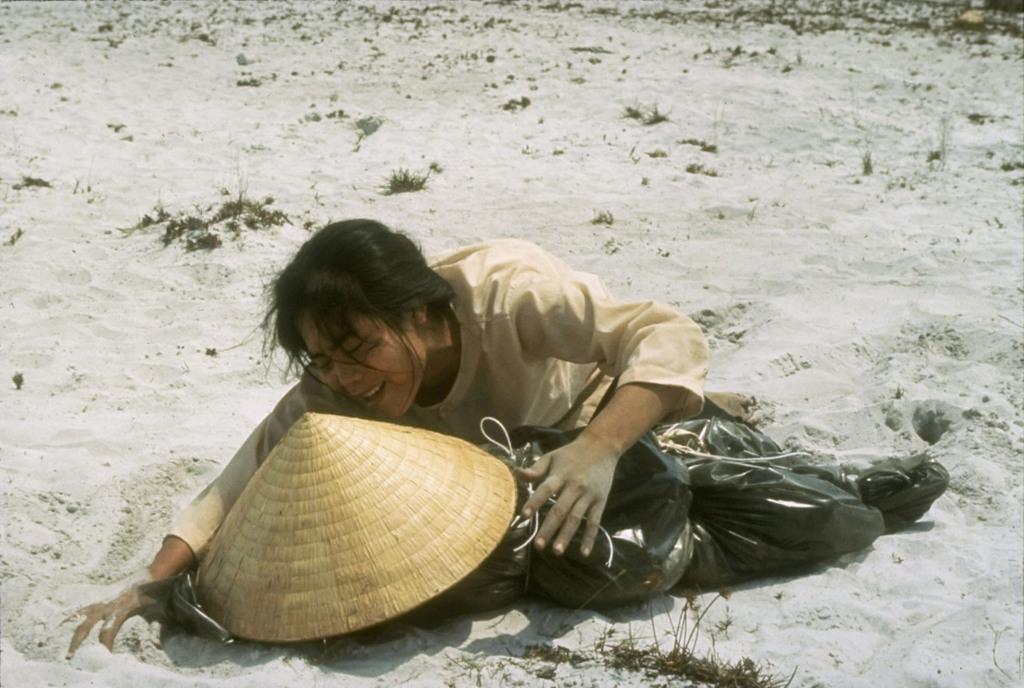In one or two sentences, can you explain what this image depicts? The woman in cream T-shirt is lying on the sand. I think she is crying. Beside her, we see a black color plastic cover and an umbrella shaped hat. At the bottom of the picture, we see the sand and the grass. 